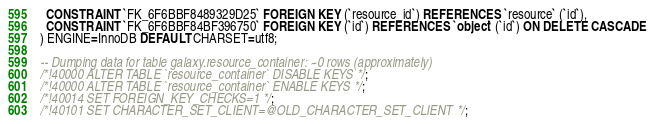<code> <loc_0><loc_0><loc_500><loc_500><_SQL_>  CONSTRAINT `FK_6F6BBF8489329D25` FOREIGN KEY (`resource_id`) REFERENCES `resource` (`id`),
  CONSTRAINT `FK_6F6BBF84BF396750` FOREIGN KEY (`id`) REFERENCES `object` (`id`) ON DELETE CASCADE
) ENGINE=InnoDB DEFAULT CHARSET=utf8;

-- Dumping data for table galaxy.resource_container: ~0 rows (approximately)
/*!40000 ALTER TABLE `resource_container` DISABLE KEYS */;
/*!40000 ALTER TABLE `resource_container` ENABLE KEYS */;
/*!40014 SET FOREIGN_KEY_CHECKS=1 */;
/*!40101 SET CHARACTER_SET_CLIENT=@OLD_CHARACTER_SET_CLIENT */;
</code> 